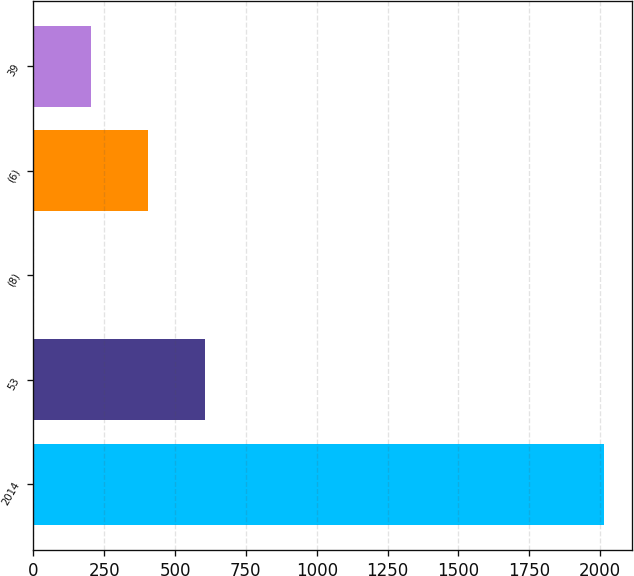Convert chart. <chart><loc_0><loc_0><loc_500><loc_500><bar_chart><fcel>2014<fcel>53<fcel>(8)<fcel>(6)<fcel>39<nl><fcel>2013<fcel>604.6<fcel>1<fcel>403.4<fcel>202.2<nl></chart> 